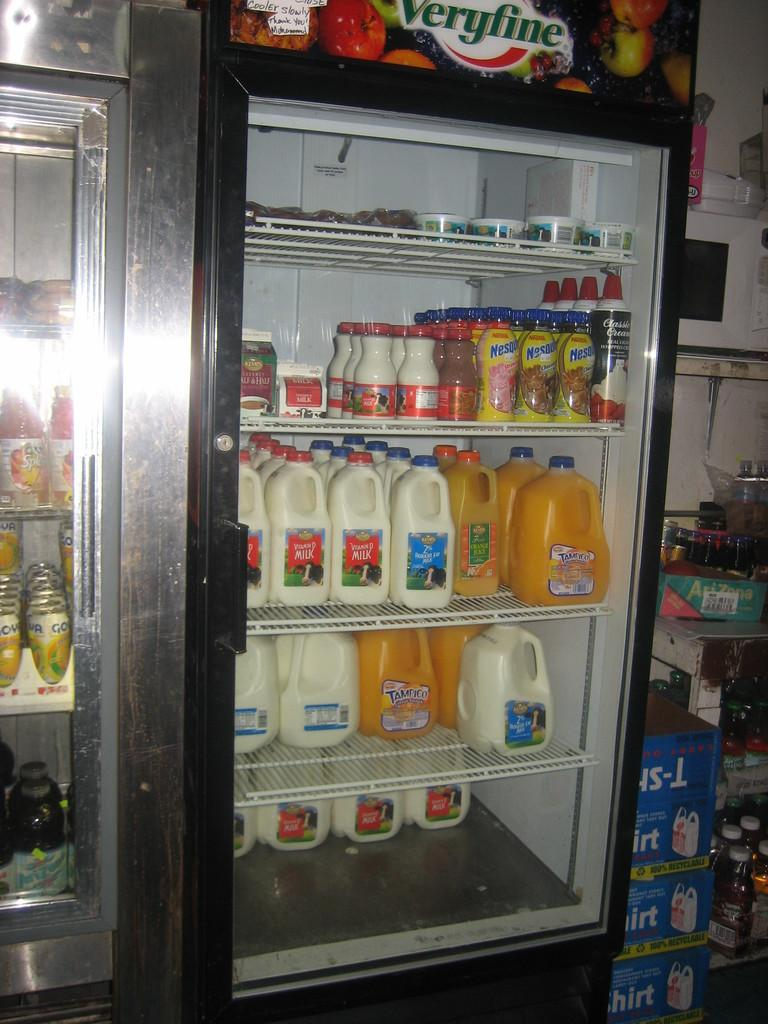<image>
Render a clear and concise summary of the photo. A drink cooler at a store holds gallons of Tampico Citrus Punch, milk, bottles of Nesquik, and Classic Cream whipped cream. 